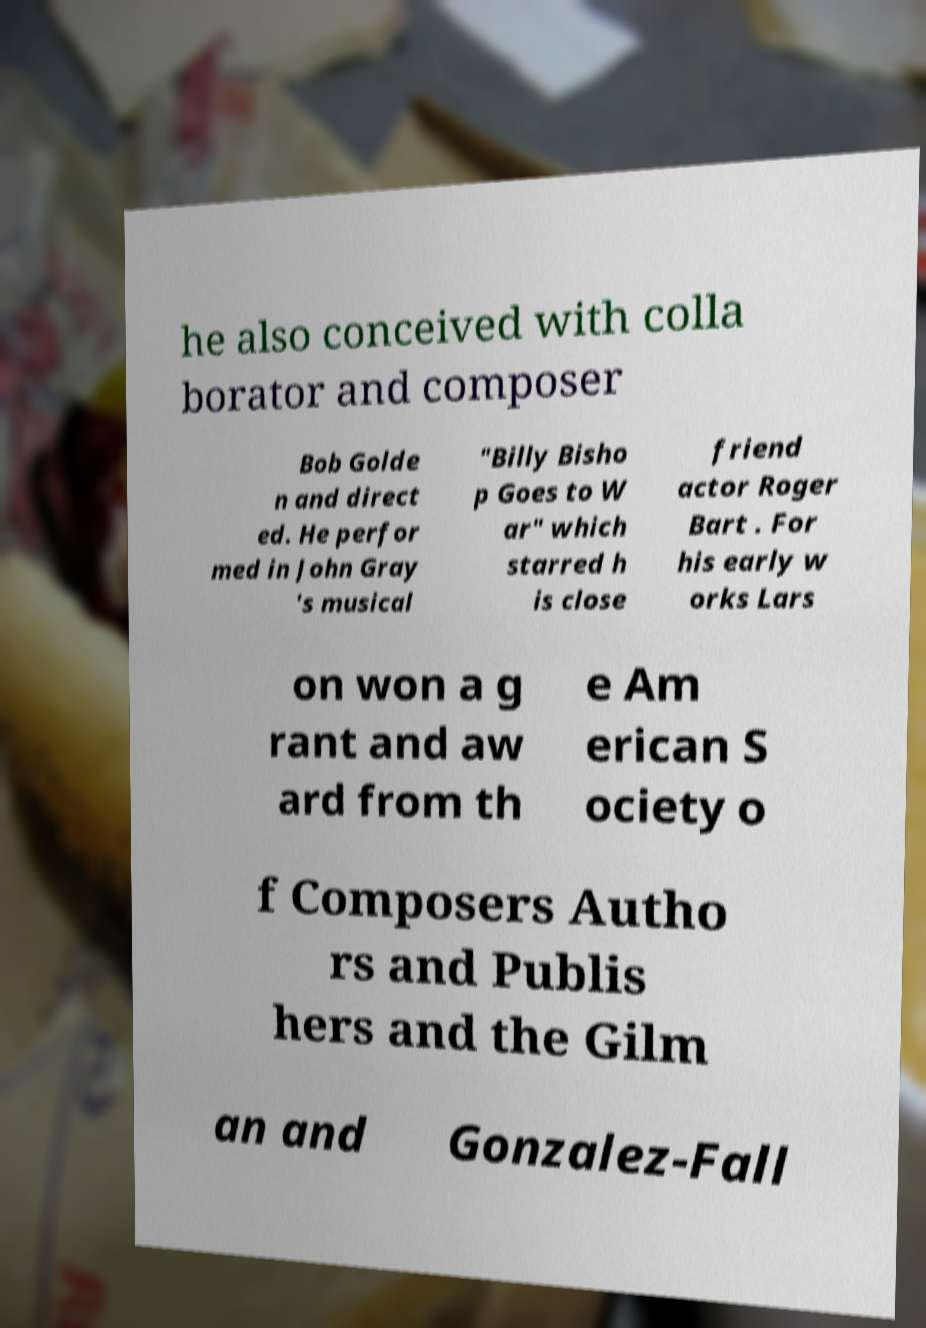Could you assist in decoding the text presented in this image and type it out clearly? he also conceived with colla borator and composer Bob Golde n and direct ed. He perfor med in John Gray 's musical "Billy Bisho p Goes to W ar" which starred h is close friend actor Roger Bart . For his early w orks Lars on won a g rant and aw ard from th e Am erican S ociety o f Composers Autho rs and Publis hers and the Gilm an and Gonzalez-Fall 